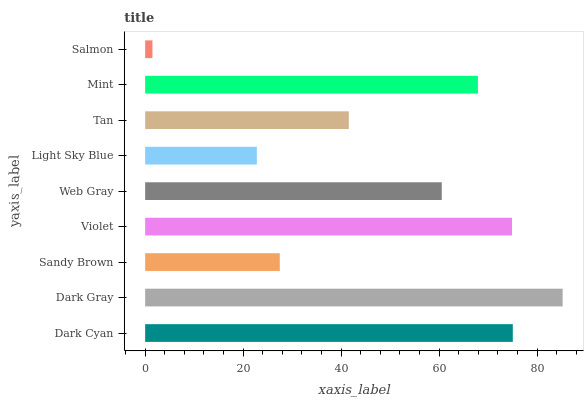Is Salmon the minimum?
Answer yes or no. Yes. Is Dark Gray the maximum?
Answer yes or no. Yes. Is Sandy Brown the minimum?
Answer yes or no. No. Is Sandy Brown the maximum?
Answer yes or no. No. Is Dark Gray greater than Sandy Brown?
Answer yes or no. Yes. Is Sandy Brown less than Dark Gray?
Answer yes or no. Yes. Is Sandy Brown greater than Dark Gray?
Answer yes or no. No. Is Dark Gray less than Sandy Brown?
Answer yes or no. No. Is Web Gray the high median?
Answer yes or no. Yes. Is Web Gray the low median?
Answer yes or no. Yes. Is Tan the high median?
Answer yes or no. No. Is Light Sky Blue the low median?
Answer yes or no. No. 